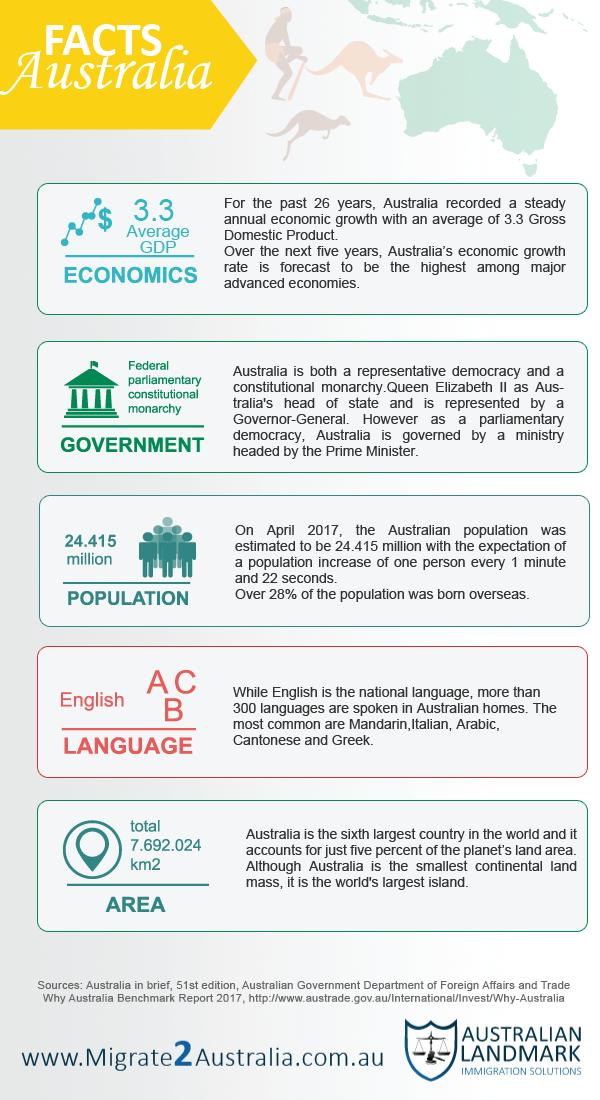Outline some significant characteristics in this image. As of April 2017, the estimated population of Australia was approximately 24.415 million. The total area of Australia is approximately 7,692,024 kilometers squared. Australia is a federal parliamentary constitutional monarchy, where the government is comprised of a system of three branches: the legislative, executive, and judicial. The monarch serves as the ceremonial head of state, while the prime minister serves as the head of government and is responsible for the executive branch. The legislative branch is composed of the Senate and the House of Representatives, which are responsible for making laws and overseeing the government. 